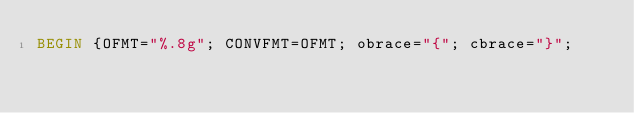Convert code to text. <code><loc_0><loc_0><loc_500><loc_500><_Awk_>BEGIN {OFMT="%.8g"; CONVFMT=OFMT; obrace="{"; cbrace="}"; </code> 